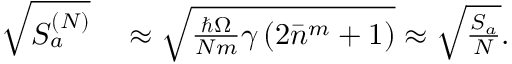Convert formula to latex. <formula><loc_0><loc_0><loc_500><loc_500>\begin{array} { r l } { \sqrt { S _ { a } ^ { ( N ) } } } & \approx \sqrt { \frac { \hbar { \Omega } } { N m } \gamma \left ( 2 \bar { n } ^ { m } + 1 \right ) } \approx \sqrt { \frac { S _ { a } } { N } } . } \end{array}</formula> 